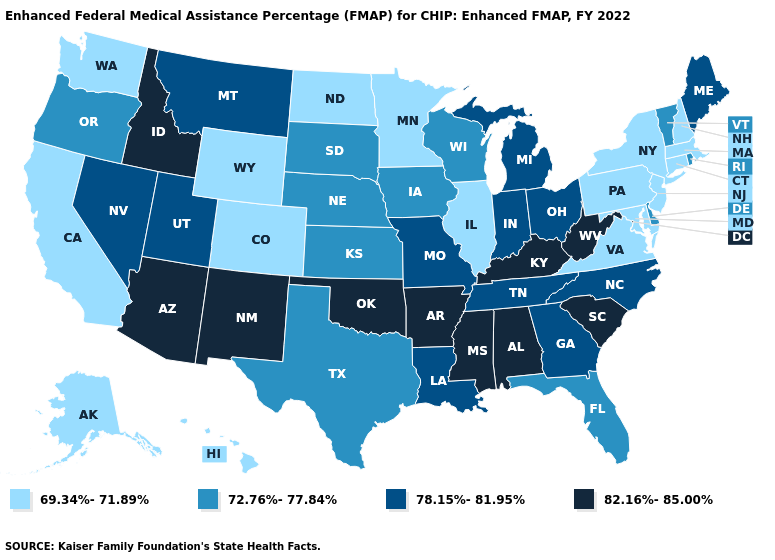Name the states that have a value in the range 78.15%-81.95%?
Answer briefly. Georgia, Indiana, Louisiana, Maine, Michigan, Missouri, Montana, Nevada, North Carolina, Ohio, Tennessee, Utah. Name the states that have a value in the range 78.15%-81.95%?
Quick response, please. Georgia, Indiana, Louisiana, Maine, Michigan, Missouri, Montana, Nevada, North Carolina, Ohio, Tennessee, Utah. What is the highest value in the USA?
Answer briefly. 82.16%-85.00%. What is the lowest value in the USA?
Concise answer only. 69.34%-71.89%. Among the states that border Wisconsin , does Michigan have the highest value?
Give a very brief answer. Yes. Name the states that have a value in the range 72.76%-77.84%?
Short answer required. Delaware, Florida, Iowa, Kansas, Nebraska, Oregon, Rhode Island, South Dakota, Texas, Vermont, Wisconsin. What is the value of Kentucky?
Be succinct. 82.16%-85.00%. Which states have the lowest value in the USA?
Answer briefly. Alaska, California, Colorado, Connecticut, Hawaii, Illinois, Maryland, Massachusetts, Minnesota, New Hampshire, New Jersey, New York, North Dakota, Pennsylvania, Virginia, Washington, Wyoming. Which states have the lowest value in the Northeast?
Be succinct. Connecticut, Massachusetts, New Hampshire, New Jersey, New York, Pennsylvania. Name the states that have a value in the range 72.76%-77.84%?
Short answer required. Delaware, Florida, Iowa, Kansas, Nebraska, Oregon, Rhode Island, South Dakota, Texas, Vermont, Wisconsin. What is the value of Florida?
Be succinct. 72.76%-77.84%. What is the value of South Dakota?
Keep it brief. 72.76%-77.84%. What is the highest value in the Northeast ?
Be succinct. 78.15%-81.95%. Name the states that have a value in the range 69.34%-71.89%?
Short answer required. Alaska, California, Colorado, Connecticut, Hawaii, Illinois, Maryland, Massachusetts, Minnesota, New Hampshire, New Jersey, New York, North Dakota, Pennsylvania, Virginia, Washington, Wyoming. Does Colorado have the highest value in the West?
Give a very brief answer. No. 